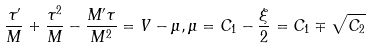Convert formula to latex. <formula><loc_0><loc_0><loc_500><loc_500>\frac { \tau ^ { \prime } } { M } + \frac { \tau ^ { 2 } } { M } - \frac { M ^ { \prime } \tau } { M ^ { 2 } } = V - \mu , \mu = C _ { 1 } - \frac { \xi } { 2 } = C _ { 1 } \mp \sqrt { C _ { 2 } }</formula> 